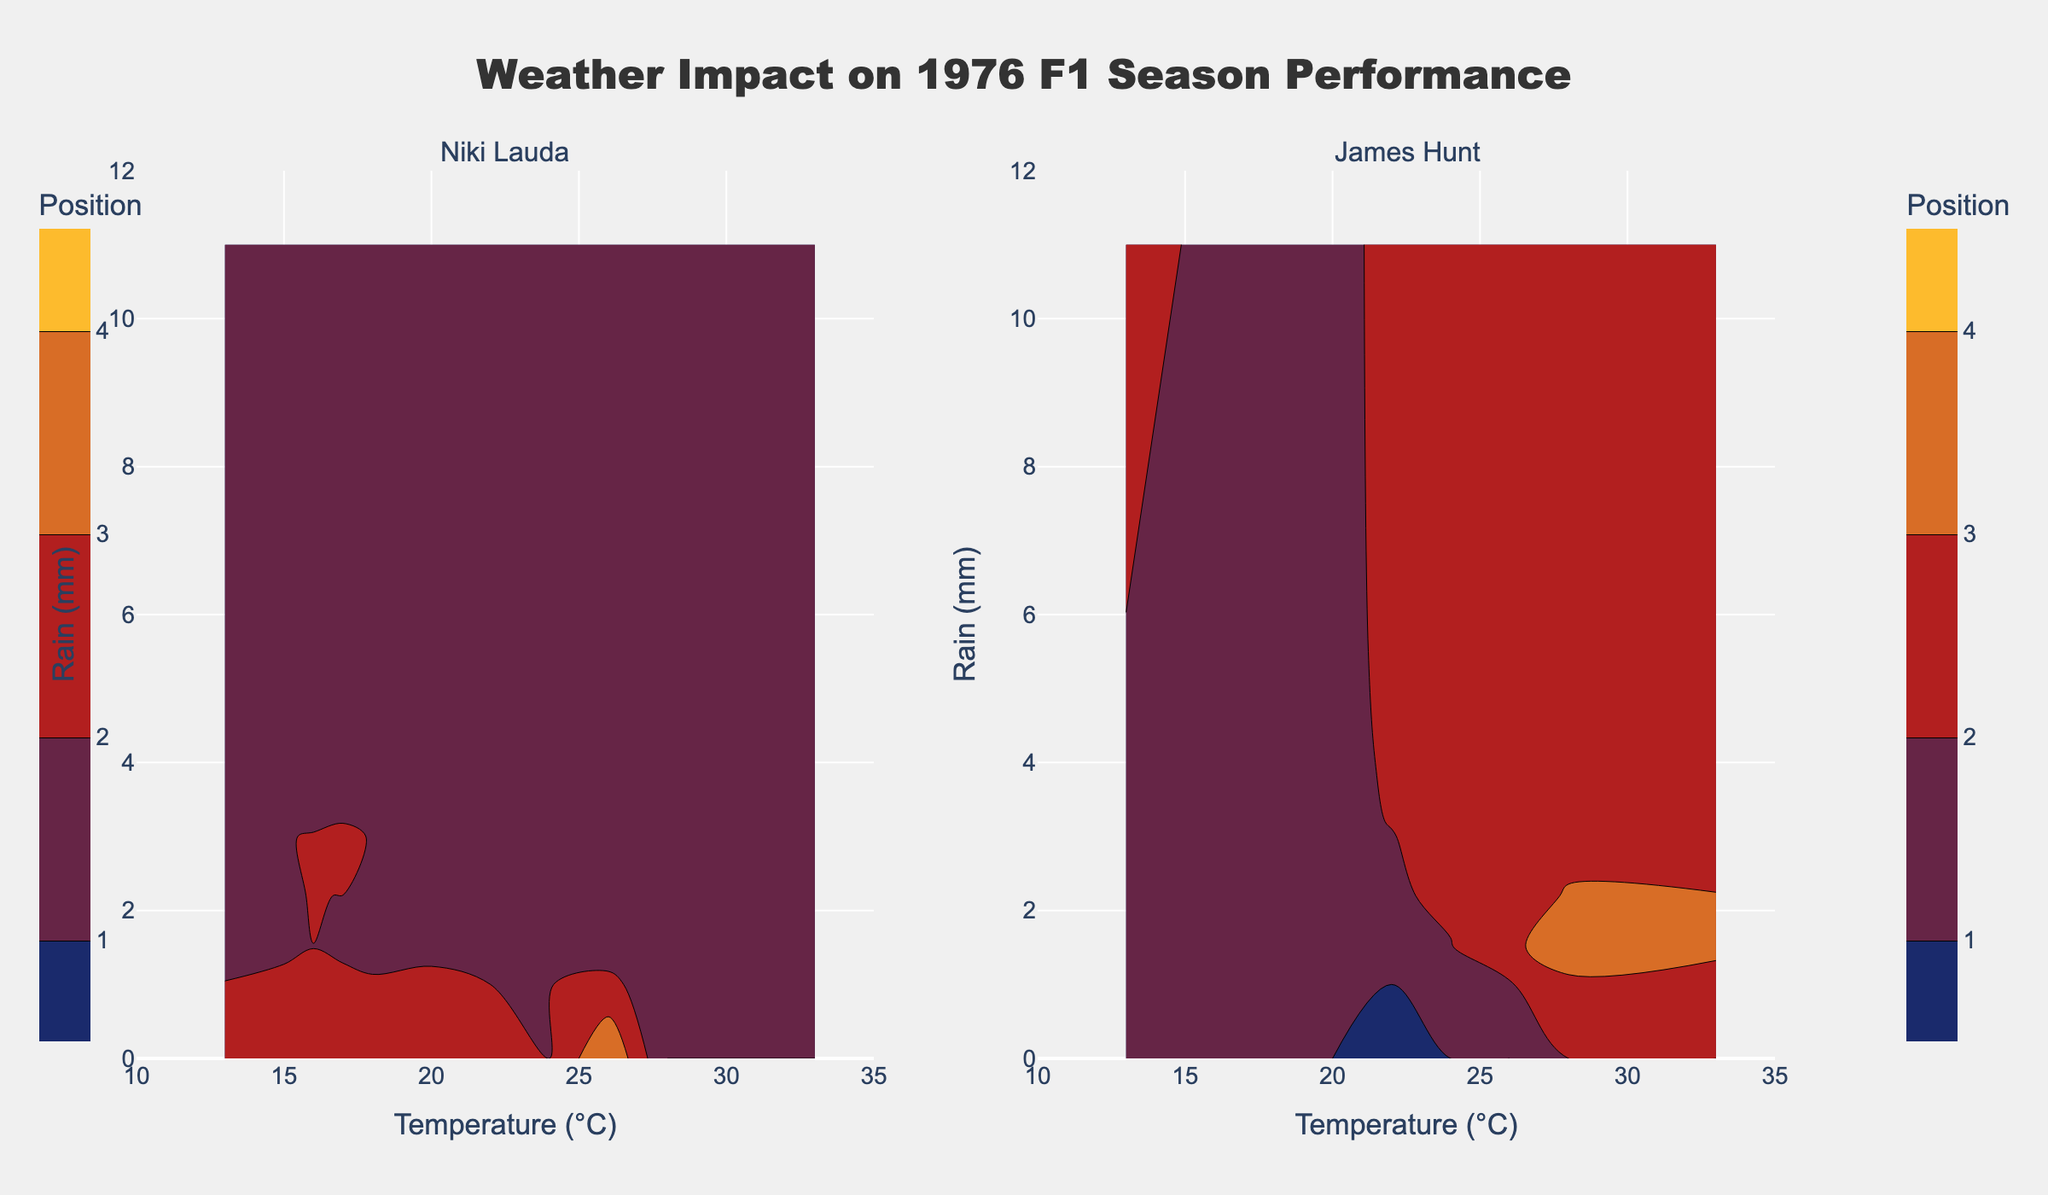Which driver generally performed better in dry conditions? Looking at the subplot spaces with zero mm rain, where temperature changes, Niki Lauda appears to have more wins and higher positions in dry conditions compared to James Hunt.
Answer: Niki Lauda How does Niki Lauda’s performance change with increasing rain? Observing Niki Lauda's subplot, his position worsens in conditions with rain over 3 mm, with a notable DNF in extremely high rain conditions at Nürburgring and Fuji.
Answer: It worsens Which driver has a better average position in wet conditions (> 3 mm rain)? Calculating the average positions under wet conditions (>3 mm rain) for both drivers from the contour plots, James Hunt has fewer DNFs and better average finishes compared to Niki Lauda.
Answer: James Hunt What is the lowest temperature range noted in the figure, and how does rain vary at that temperature? The lowest temperature range noted in the subplots is 13°C. Both drivers experienced extremely high rain of 11 mm.
Answer: 13°C; 11 mm Do both drivers have better performance at medium rain levels (1-3 mm) compared to high levels (over 3 mm)? Referring to the contour plots, the medium rain levels are marked with relatively better positions than high rain levels for both drivers; Lauda’s wins and positions up to 3rd place fall within medium rain levels. For higher rain levels, both drivers struggled, and DNF occurrences are marked.
Answer: Yes Which driver likely benefited more from dry and cooler (≤ 20°C) race conditions? In the subplot areas indicating temperatures ≤ 20°C and dry conditions, James Hunt secured multiple wins (Anderstorp and Long Beach), suggesting better performance compared to Lauda, whose positions varied more.
Answer: James Hunt What was Niki Lauda's best performance in the wettest race conditions? From the contour plot for Niki Lauda, his best position in wettest conditions is noted as 1st in Jarama at 18°C and 2.2 mm of rain.
Answer: 1st How did James Hunt perform at the lowest temperature condition? For the lowest temperature at 13°C, James Hunt had a position of 3rd, with 11 mm of rainfall in Fuji.
Answer: 3rd 